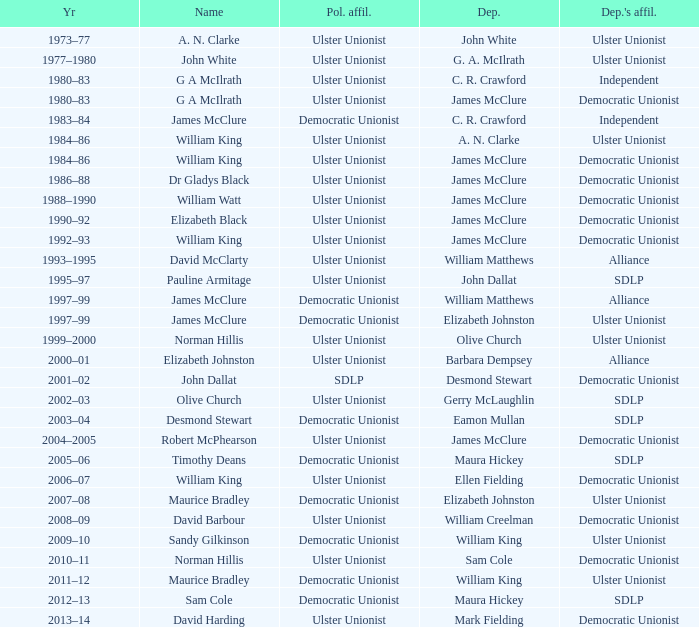What is the Deputy's affiliation in 1992–93? Democratic Unionist. 